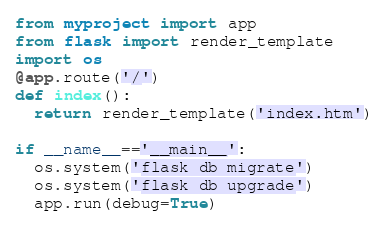<code> <loc_0><loc_0><loc_500><loc_500><_Python_>from myproject import app
from flask import render_template
import os
@app.route('/')
def index():
  return render_template('index.htm')

if __name__=='__main__':
  os.system('flask db migrate')
  os.system('flask db upgrade')
  app.run(debug=True)</code> 